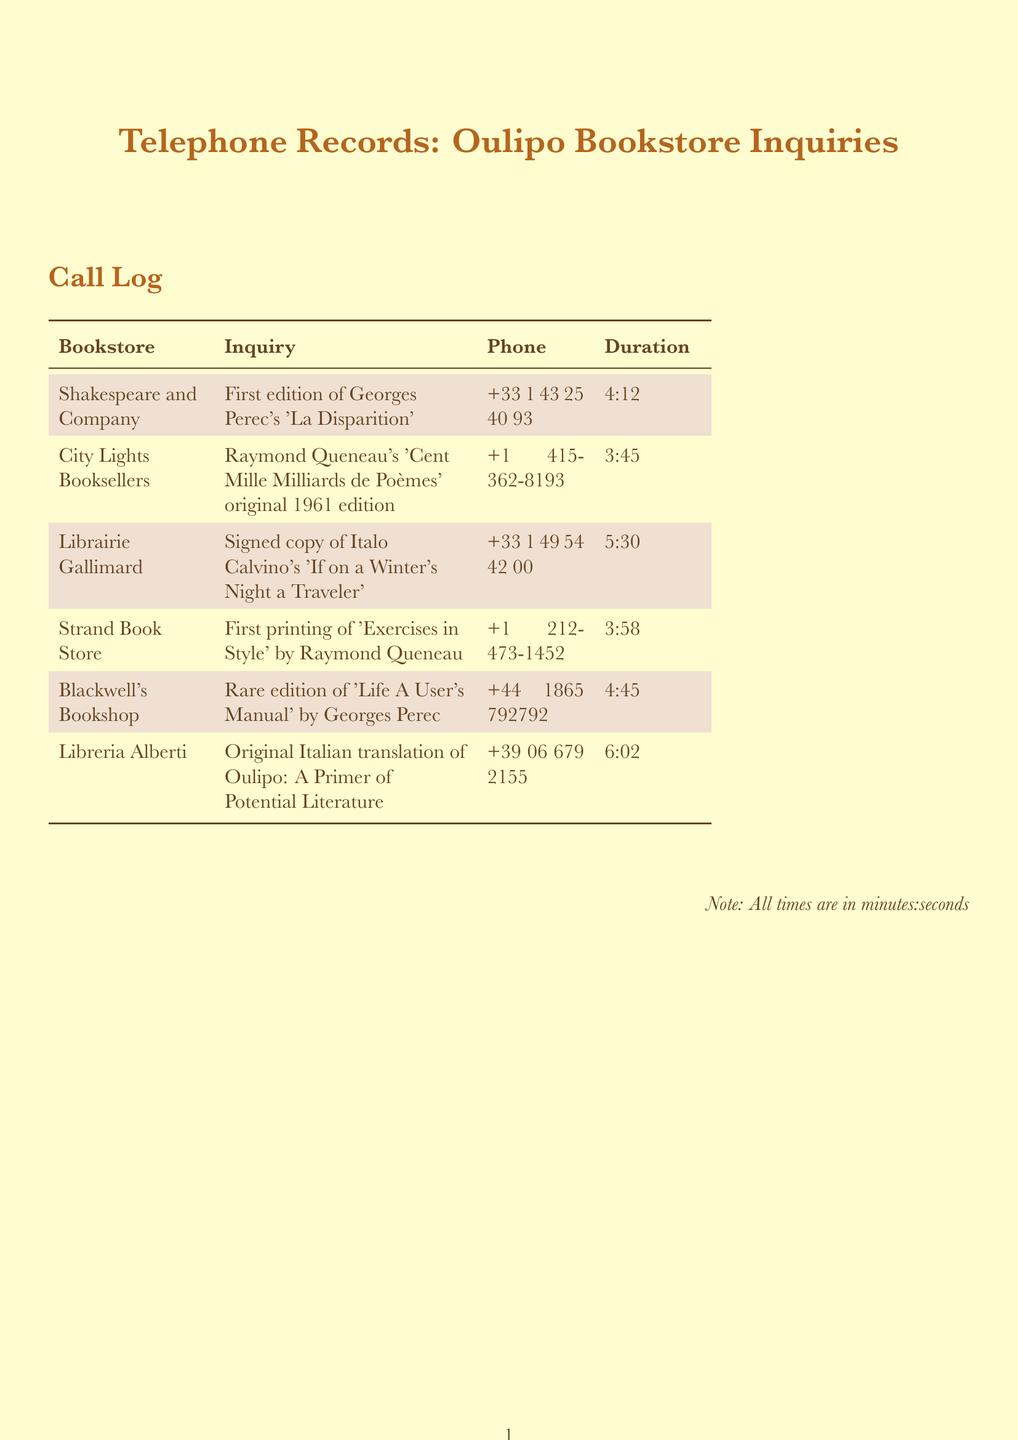What is the first edition inquired about at Shakespeare and Company? The inquiry at Shakespeare and Company was about the first edition of Georges Perec's 'La Disparition'.
Answer: 'La Disparition' What is the phone number for City Lights Booksellers? The document lists the phone number for City Lights Booksellers as +1 415-362-8193.
Answer: +1 415-362-8193 Which bookstore was contacted about a signed copy of Italo Calvino's work? The called bookstore regarding a signed copy of Italo Calvino's work was Librairie Gallimard.
Answer: Librairie Gallimard How long was the call to Blackwell's Bookshop? The call duration to Blackwell's Bookshop is noted as 4 minutes and 45 seconds.
Answer: 4:45 Which publication was inquired about at Libreria Alberti? The inquiry at Libreria Alberti was about the original Italian translation of Oulipo: A Primer of Potential Literature.
Answer: Oulipo: A Primer of Potential Literature What is the total number of bookstores listed in the records? The total number of bookstores mentioned in the document is six.
Answer: 6 Which author’s work was addressed in the context of the first printing at Strand Book Store? The author whose work was addressed at Strand Book Store is Raymond Queneau.
Answer: Raymond Queneau What type of document is this? The document is a telephone record log detailing inquiries made to bookstores.
Answer: telephone record log 